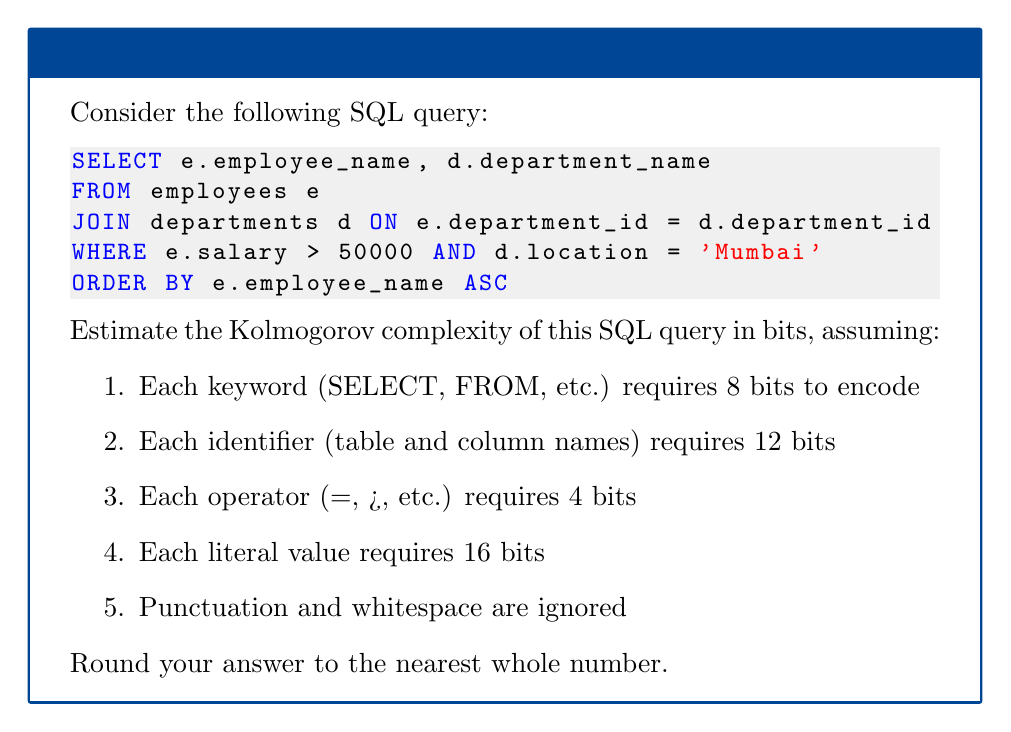Provide a solution to this math problem. Let's break down the query and calculate the bits required for each component:

1. Keywords:
   - SELECT, FROM, JOIN, ON, WHERE, AND, ORDER BY, ASC
   - 8 keywords × 8 bits = 64 bits

2. Identifiers:
   - e, employee_name, d, department_name, employees, departments, e, department_id, d, department_id, e, salary, d, location, e, employee_name
   - 16 identifiers × 12 bits = 192 bits

3. Operators:
   - =, >, =
   - 3 operators × 4 bits = 12 bits

4. Literal values:
   - 50000, 'Mumbai'
   - 2 literals × 16 bits = 32 bits

Total bits:
$$ 64 + 192 + 12 + 32 = 300 \text{ bits} $$

This estimation provides a rough measure of the Kolmogorov complexity of the SQL query. The Kolmogorov complexity is the length of the shortest program that can produce the given string (in this case, the SQL query). Our encoding scheme is a simplified representation and may not be the most optimal, but it gives a reasonable approximation.

It's worth noting that this estimation doesn't account for the inherent structure of SQL, which could potentially allow for more efficient encoding. However, for the purposes of this exercise, our simplified encoding scheme provides a reasonable estimate of the query's complexity.
Answer: 300 bits 